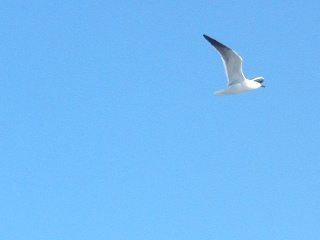What is the animal that the sky is behind of? The animal in the image is a bird, likely a seagull, soaring through the sky. 